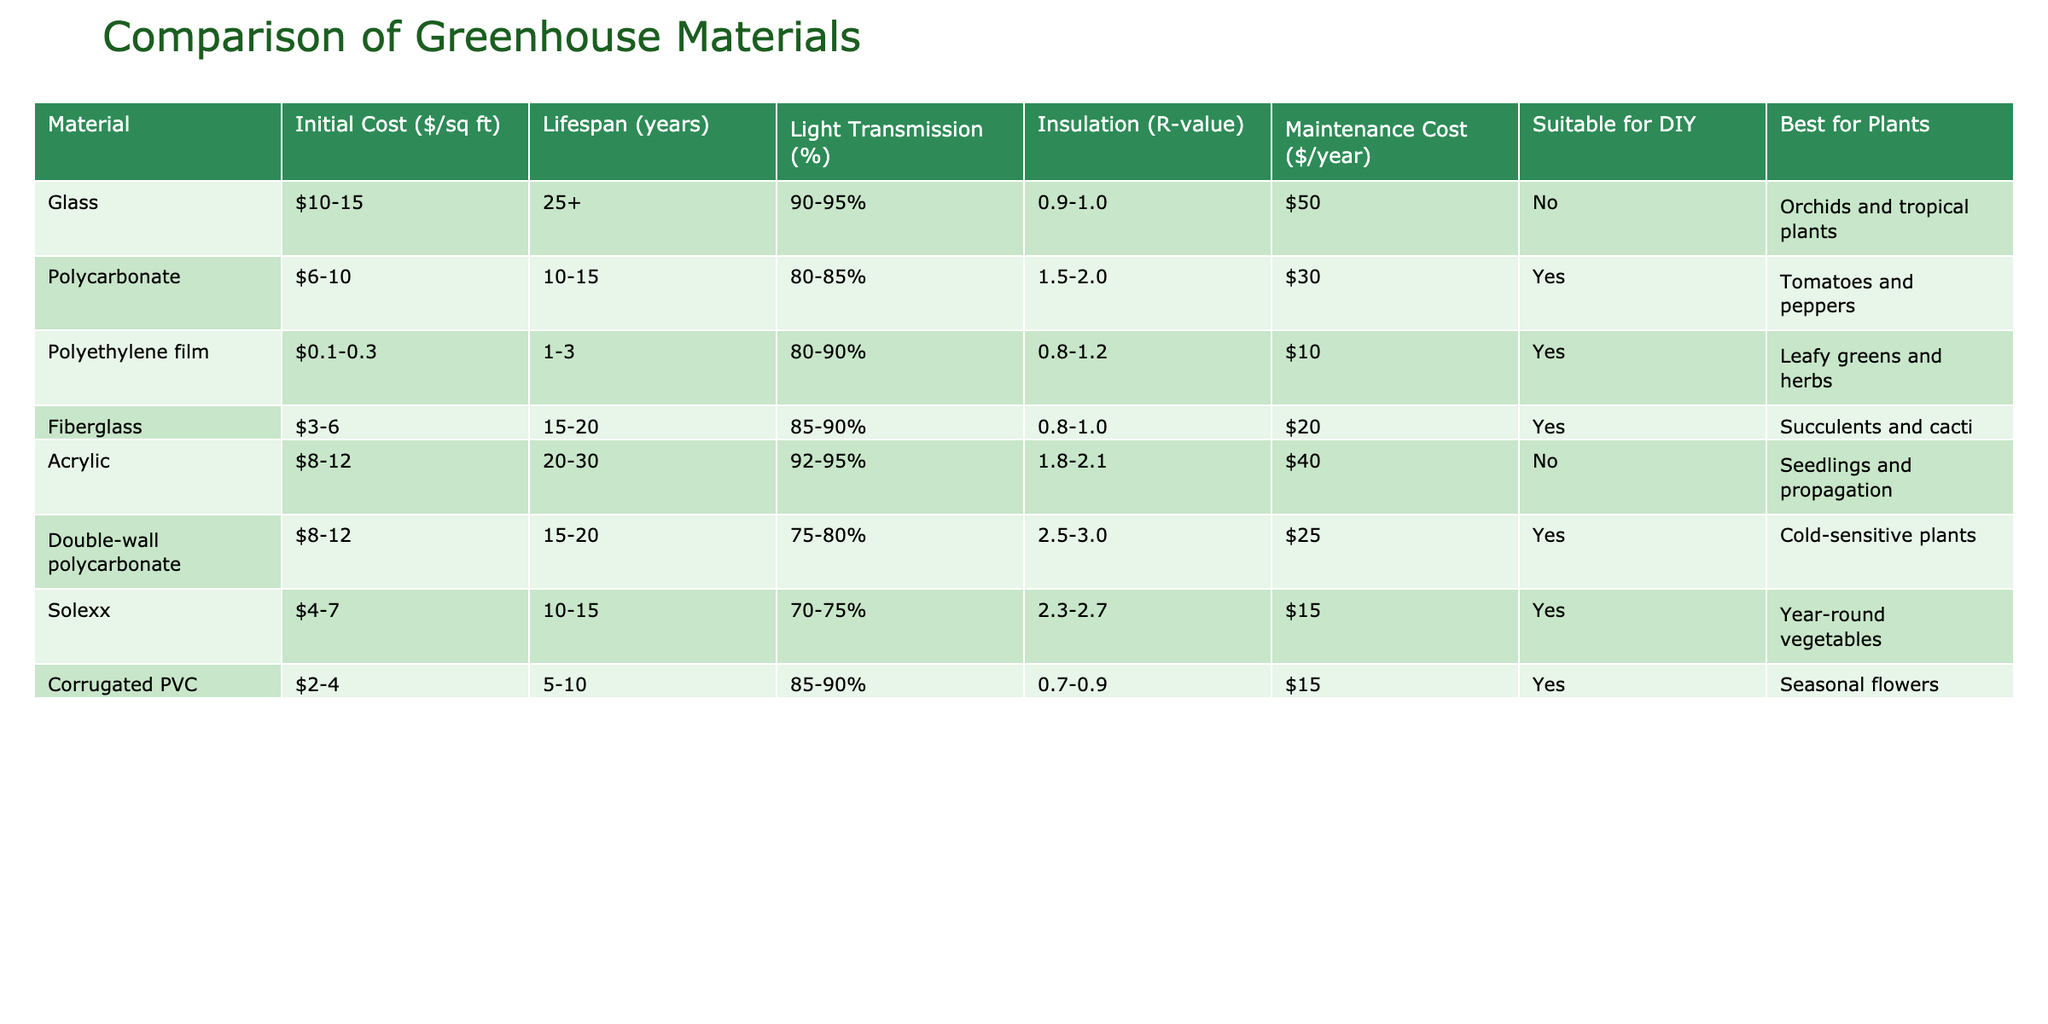What is the initial cost per square foot of Polyethylene film? The table lists the "Initial Cost ($/sq ft)" for Polyethylene film as 0.1-0.3. This is a direct retrieval from the table.
Answer: 0.1-0.3 Which material has the longest lifespan? From the Lifespan (years) column in the table, Glass has a lifespan of 25+ years, which is the highest compared to other materials.
Answer: Glass What is the average maintenance cost for materials that are suitable for DIY? Suitable materials for DIY from the table include Polycarbonate, Polyethylene film, Fiberglass, Double-wall polycarbonate, Solexx, and Corrugated PVC. Their maintenance costs are 30, 10, 20, 25, 15, and 15, respectively. The average is calculated as follows: (30 + 10 + 20 + 25 + 15 + 15) / 6 = 15.83.
Answer: 15.83 Is Acrylic suitable for DIY projects? The table indicates "No" under Suitable for DIY for Acrylic, which directly answers the question based on the visual data.
Answer: No Which material has the highest light transmission percentage? Checking the Light Transmission (%) column, Acrylic offers the highest transmission percentage at 92-95%. This is a retrieval question that is easily answerabale from the table.
Answer: 92-95 What is the difference in R-value between Double-wall polycarbonate and Solexx? The R-value for Double-wall polycarbonate is 2.5-3.0 and for Solexx, it is 2.3-2.7. The difference can be found by considering the midpoints of these ranges: (3.0 - 2.7) = 0.3 (considering maximum R-value).
Answer: 0.3 Which material is best for orchids and tropical plants? The table specifies that Glass is best for orchids and tropical plants. This is obtained by looking under the "Best for Plants" column and retrieving the corresponding material for these plants.
Answer: Glass How many materials have an initial cost less than $5? From the table, the materials with an initial cost less than $5 are Polyethylene film (0.1-0.3), Fiberglass (3-6), and Corrugated PVC (2-4). Counting these gives a total of three materials.
Answer: 3 What is the Insulation (R-value) of the material best suited for cold-sensitive plants? The material best suited for cold-sensitive plants is Double-wall polycarbonate, which has an R-value of 2.5-3.0 according to the table. This is retrieved directly from the Insulation (R-value) column for the relevant material.
Answer: 2.5-3.0 